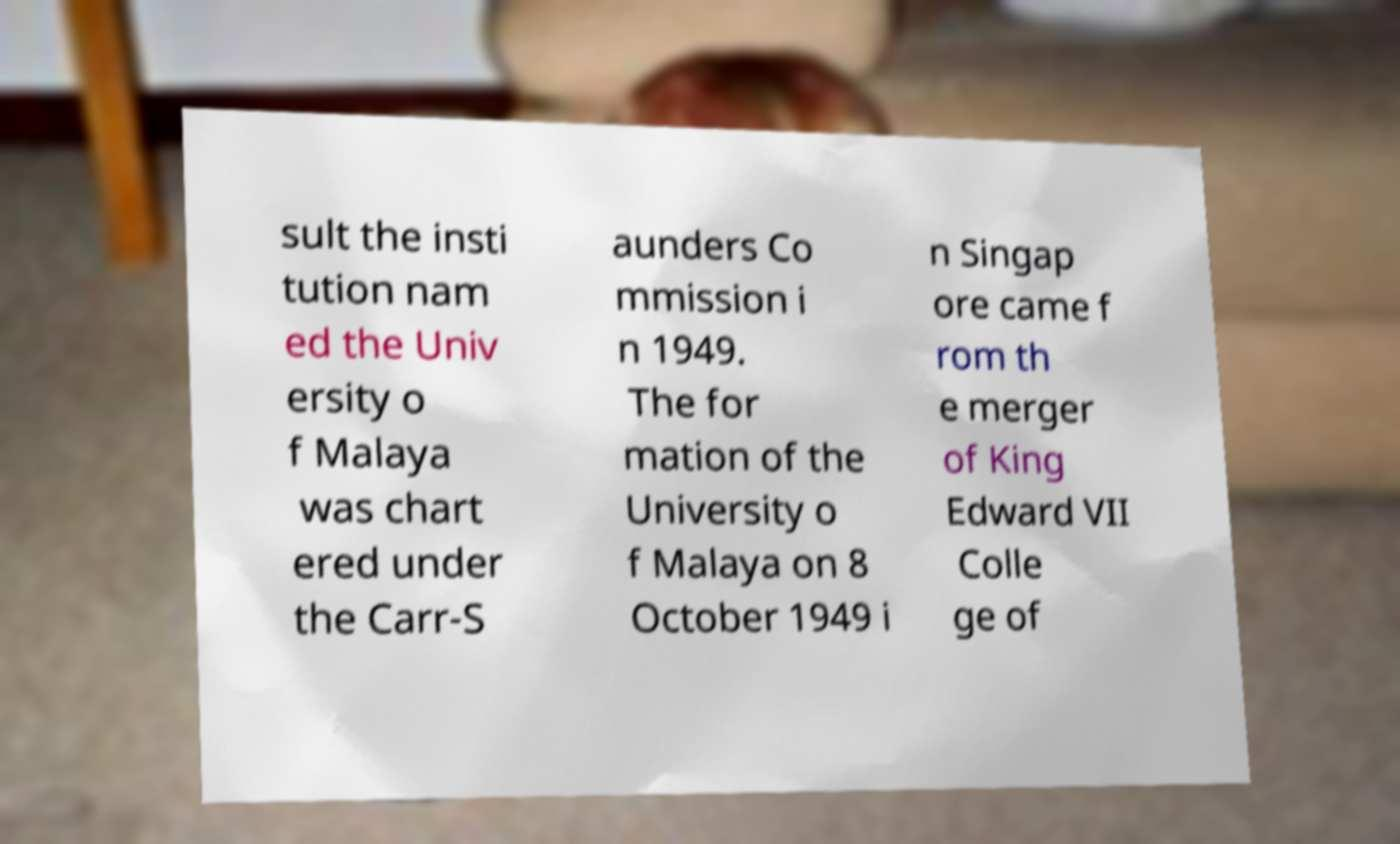Could you assist in decoding the text presented in this image and type it out clearly? sult the insti tution nam ed the Univ ersity o f Malaya was chart ered under the Carr-S aunders Co mmission i n 1949. The for mation of the University o f Malaya on 8 October 1949 i n Singap ore came f rom th e merger of King Edward VII Colle ge of 